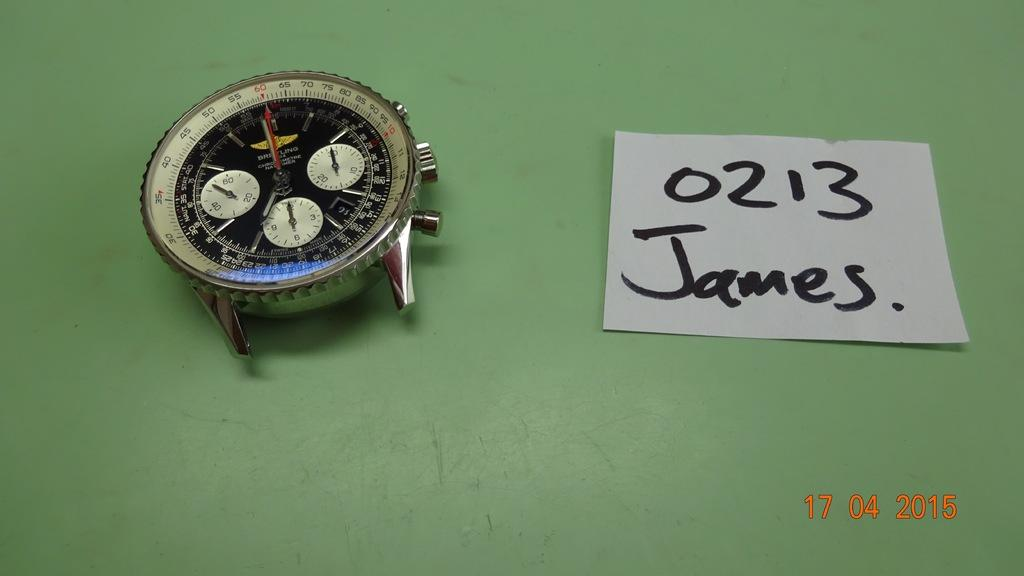<image>
Provide a brief description of the given image. A watch face on a green counter and a note beside it with 0213 James written on it. 